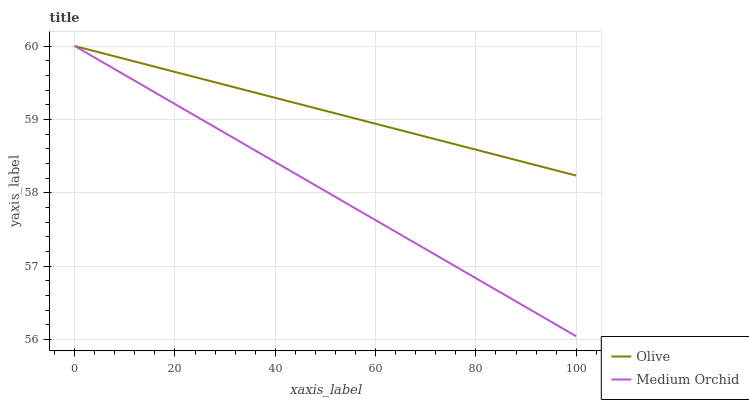Does Medium Orchid have the minimum area under the curve?
Answer yes or no. Yes. Does Olive have the maximum area under the curve?
Answer yes or no. Yes. Does Medium Orchid have the maximum area under the curve?
Answer yes or no. No. Is Olive the smoothest?
Answer yes or no. Yes. Is Medium Orchid the roughest?
Answer yes or no. Yes. Is Medium Orchid the smoothest?
Answer yes or no. No. Does Medium Orchid have the lowest value?
Answer yes or no. Yes. Does Medium Orchid have the highest value?
Answer yes or no. Yes. Does Medium Orchid intersect Olive?
Answer yes or no. Yes. Is Medium Orchid less than Olive?
Answer yes or no. No. Is Medium Orchid greater than Olive?
Answer yes or no. No. 